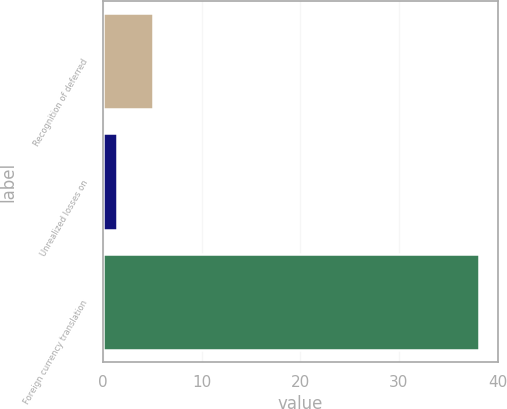Convert chart. <chart><loc_0><loc_0><loc_500><loc_500><bar_chart><fcel>Recognition of deferred<fcel>Unrealized losses on<fcel>Foreign currency translation<nl><fcel>5.07<fcel>1.4<fcel>38.1<nl></chart> 